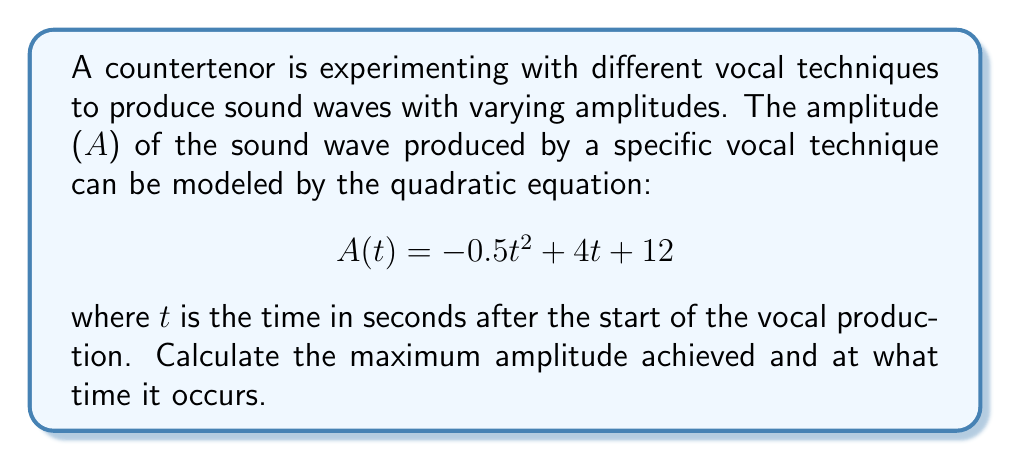Show me your answer to this math problem. To find the maximum amplitude and the time at which it occurs, we need to follow these steps:

1) The quadratic equation is in the form $A(t) = -0.5t^2 + 4t + 12$, which can be written as $A(t) = a(t-h)^2 + k$ where $(h,k)$ is the vertex of the parabola.

2) For a quadratic equation in the form $at^2 + bt + c$:
   $h = -\frac{b}{2a}$ and $k = c - \frac{b^2}{4a}$

3) In our equation, $a = -0.5$, $b = 4$, and $c = 12$

4) Calculate h:
   $h = -\frac{b}{2a} = -\frac{4}{2(-0.5)} = -\frac{4}{-1} = 4$

5) Calculate k:
   $k = c - \frac{b^2}{4a} = 12 - \frac{4^2}{4(-0.5)} = 12 - \frac{16}{-2} = 12 + 8 = 20$

6) The vertex $(h,k)$ represents the maximum point of the parabola since $a$ is negative (opens downward).

Therefore, the maximum amplitude (k) is 20, and it occurs at time (h) = 4 seconds.
Answer: The maximum amplitude is 20 units, occurring at t = 4 seconds. 